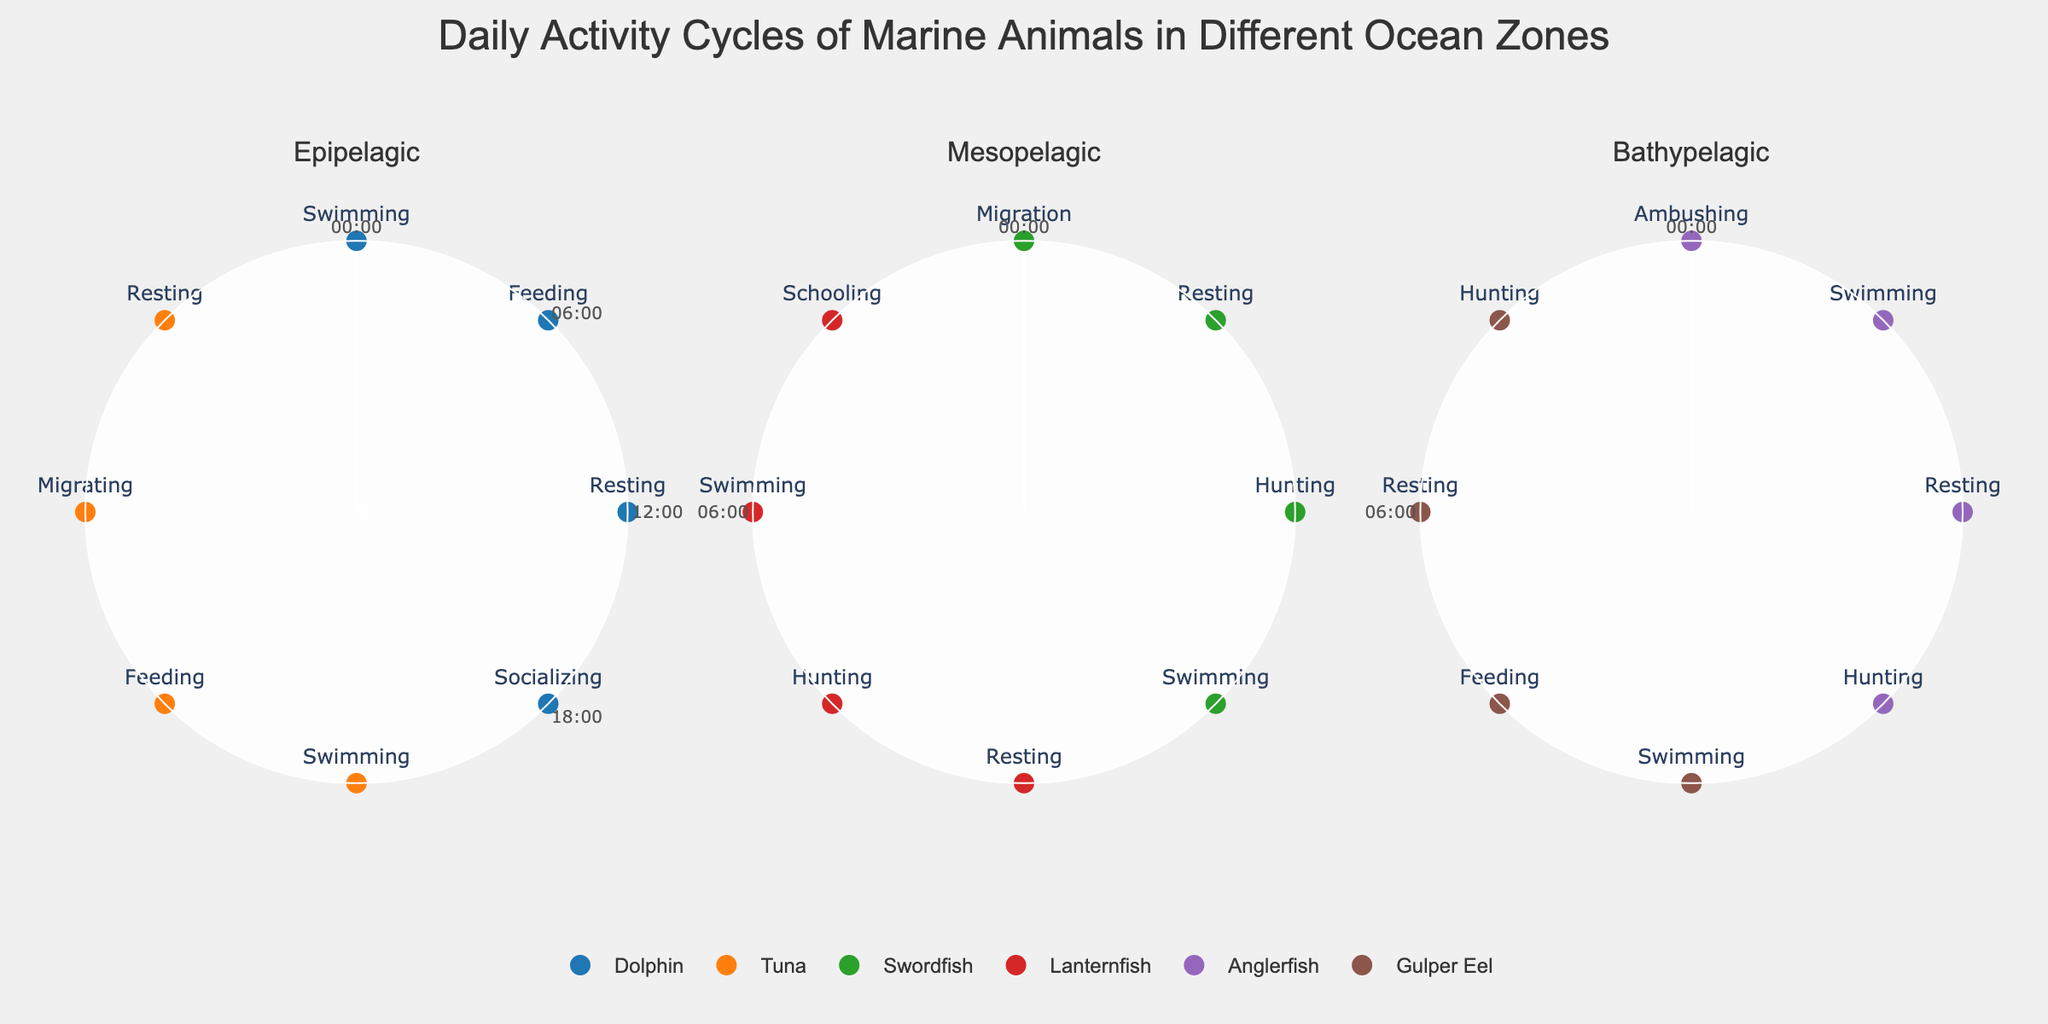Which animals are active in the Epipelagic zone between 0:00 and 6:00? In the Epipelagic zone, we look for data points at 0:00 and 6:00. The Dolphin is active at 0:00 (Swimming) and Tuna is active at 2:00 (Swimming). So, both Dolphin and Tuna are active during this period.
Answer: Dolphin, Tuna During which time does the Tuna migrate in the Epipelagic zone? In the Epipelagic subplot, we locate the Tuna's data points and find that migrating activity is listed under 14:00.
Answer: 14:00 How many activities does each animal have in the Mesopelagic zone? The Mesopelagic subplot shows two animals, Swordfish and Lanternfish. Each animal has four labeled activities around the clock.
Answer: Both have 4 activities each Comparing Dolphin and Swordfish, which starts their day earliest in terms of activity? Check the time of first activity for both animals. Dolphin starts at 0:00 with Swimming and Swordfish starts at 1:00 with Migration in the Mesopelagic zone. Thus, Dolphin starts earlier.
Answer: Dolphin What is the primary activity of Anglerfish at 22:00 in the Bathypelagic zone? In the Bathypelagic subplot, we find the data point for Anglerfish at 22:00, which is labeled as Hunting.
Answer: Hunting Are there any animals that are resting at 6:00 in any of the zones? We analyze all subplots for the 6:00 data point to identify activities. No data point indicates "Resting" at 6:00 in any of the zones.
Answer: No Which animal has a feeding activity at the latest hour throughout all the zones? Reviewing all the feeding activities’ times across subplots, Tuna's feeding at 8:00 in the Epipelagic zone and Gulper Eel's feeding at 11:00 in the Bathypelagic zone come into consideration. Gulper Eel's activity at 11:00 is the latest.
Answer: Gulper Eel How many animals exhibit swimming activity between 12:00 and 18:00 across all zones? Check for swimming activities between 12:00 and 18:00 in all the subplots. Dolphin (12:00) in Epipelagic, Swordfish (19:00) in Mesopelagic, Lanternfish (15:00) in Mesopelagic, and Anglerfish (10:00) and (17:00) in Bathypelagic swim in this period. There are no other instances.
Answer: 3 Do any animals perform more than one type of activity in a single zone? Check individual animal activities within each subplot. For example, the Swordfish does resting, hunting, migration, and swimming in the Mesopelagic zone. Thus, many animals perform more than one type of activity in their respective single zones.
Answer: Yes Which animal has a socializing activity, and at what time is it conducted? In the Epipelagic subplot, we identify that Dolphin has a socializing activity at 18:00. No other animals have socializing activity listed.
Answer: Dolphin, 18:00 